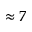Convert formula to latex. <formula><loc_0><loc_0><loc_500><loc_500>\approx 7</formula> 